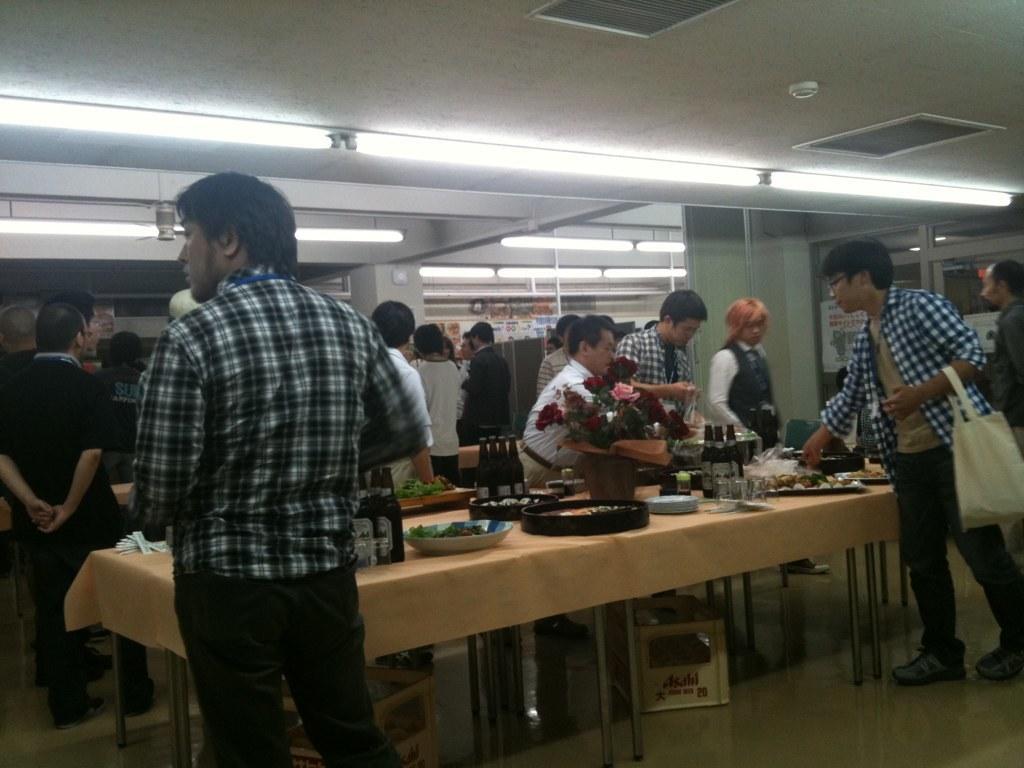Can you describe this image briefly? On the left side, there is a person in a shirt standing. On the right side, there is a person wearing a hand bad and standing on the floor in front of a table on which, there are food items arranged. In the background, there are persons standing, there are lights attached to the roof and there are pillars. 